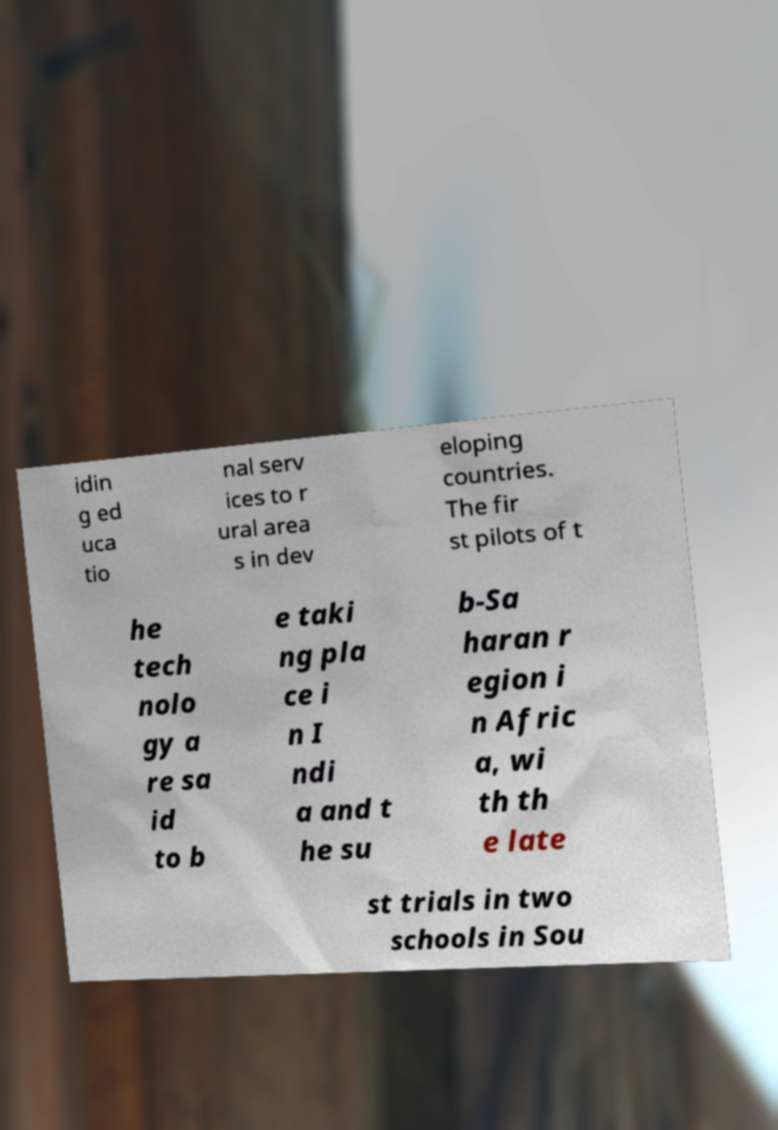Can you read and provide the text displayed in the image?This photo seems to have some interesting text. Can you extract and type it out for me? idin g ed uca tio nal serv ices to r ural area s in dev eloping countries. The fir st pilots of t he tech nolo gy a re sa id to b e taki ng pla ce i n I ndi a and t he su b-Sa haran r egion i n Afric a, wi th th e late st trials in two schools in Sou 